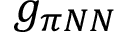<formula> <loc_0><loc_0><loc_500><loc_500>g _ { \pi N N }</formula> 